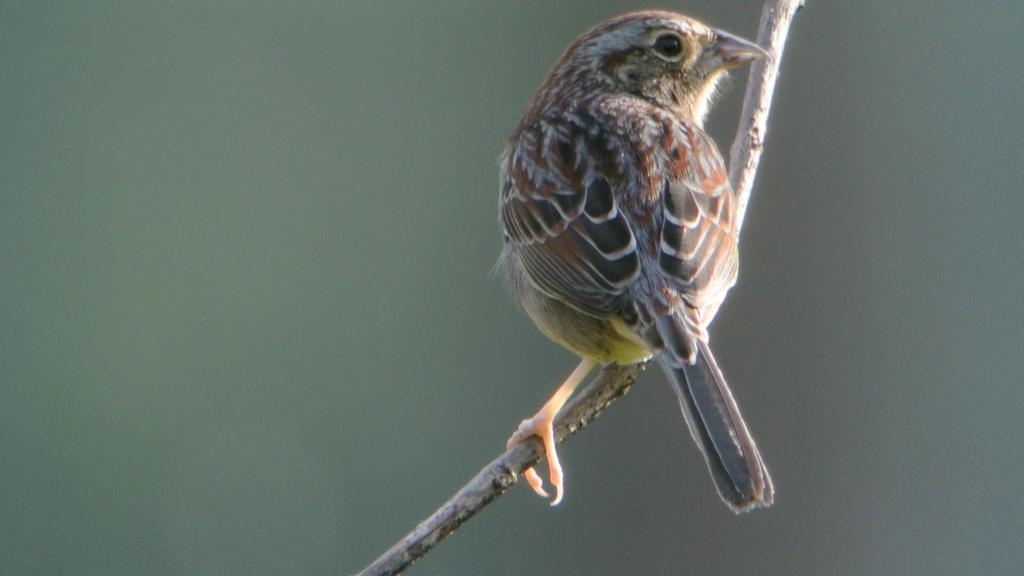What type of animal can be seen in the image? There is a bird in the image. Where is the bird located in the image? The bird is sitting on a branch. Can you describe the background of the image? The background of the image is blurred. What letter does the bird deliver in the image? There is no letter present in the image, and the bird is not delivering anything. 